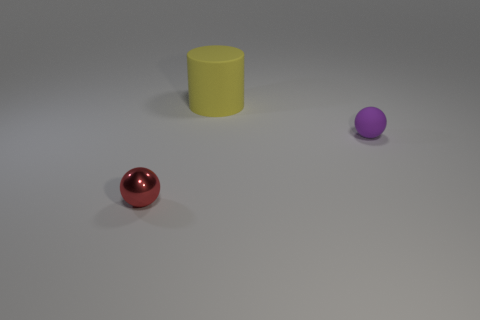Do the rubber cylinder and the matte sphere have the same color?
Provide a short and direct response. No. How many other small red things have the same shape as the small red metal thing?
Offer a terse response. 0. There is another thing that is made of the same material as the yellow object; what is its size?
Your answer should be compact. Small. Is the size of the yellow matte thing the same as the purple rubber ball?
Offer a terse response. No. Are any tiny red things visible?
Offer a terse response. Yes. There is a sphere that is on the left side of the ball that is right of the matte thing that is behind the small purple matte thing; what is its size?
Make the answer very short. Small. What number of other yellow objects are made of the same material as the big yellow object?
Provide a short and direct response. 0. What number of red metallic objects are the same size as the purple matte sphere?
Offer a terse response. 1. What material is the small thing that is in front of the sphere on the right side of the tiny thing left of the tiny purple rubber ball?
Provide a short and direct response. Metal. What number of objects are either small cyan shiny things or large yellow matte cylinders?
Give a very brief answer. 1. 